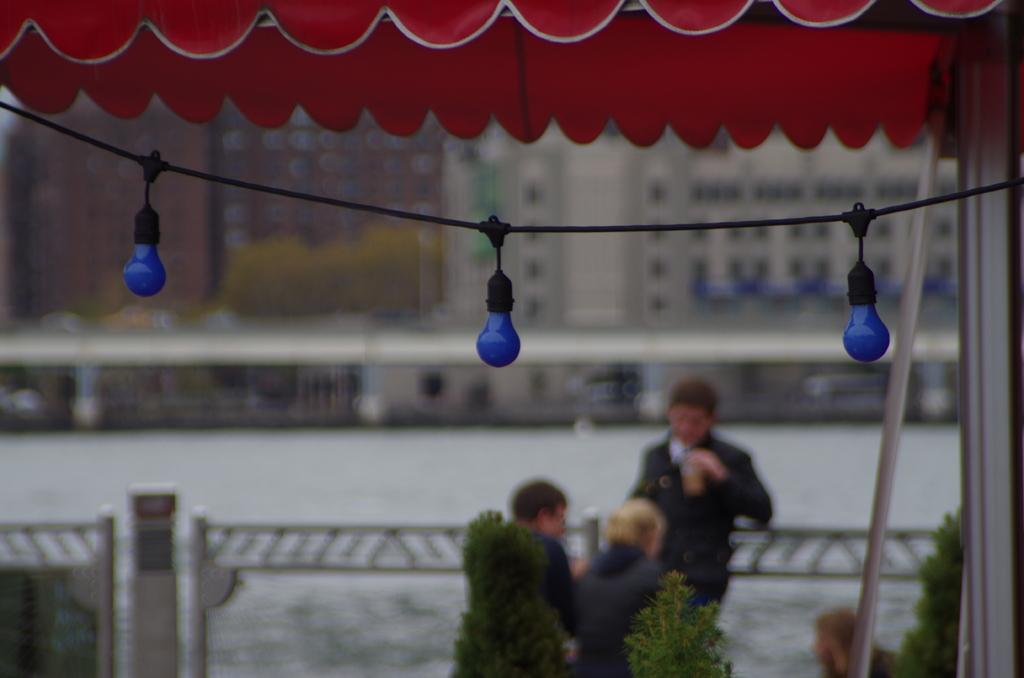How many people are in the image? There are three persons in the image. What else can be seen in the image besides the people? There are plants, a pole, bulbs, a road, and buildings in the background of the image. What might the bulbs be used for in the image? The bulbs could be used for lighting purposes, as they are often found in streetlights or other illumination sources. What type of environment is depicted in the image? The image shows an urban environment, with buildings and a road visible in the background. Can you tell me how many girls are using the scale in the image? There is no scale present in the image, and therefore no girls are using it. 